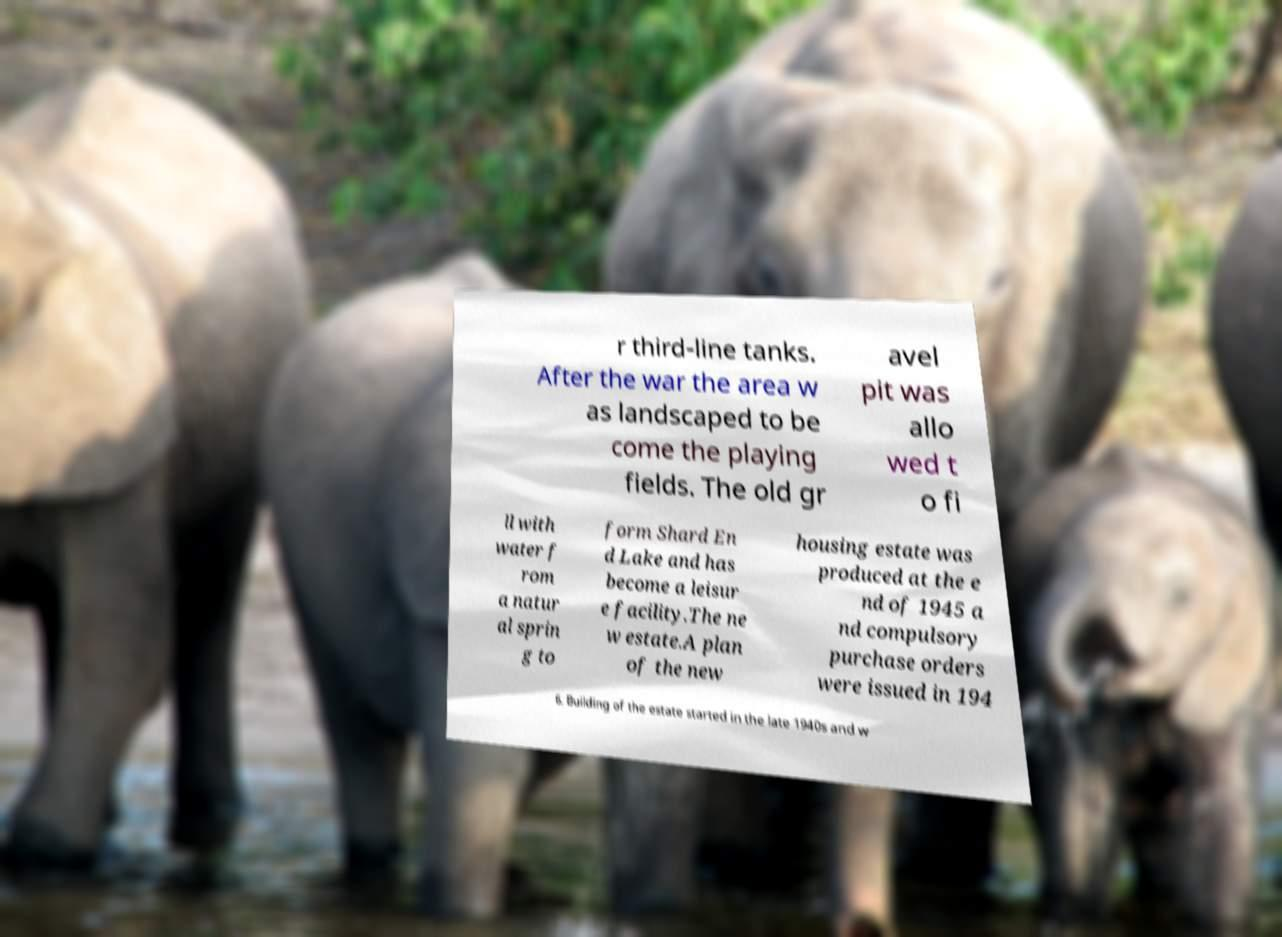What messages or text are displayed in this image? I need them in a readable, typed format. r third-line tanks. After the war the area w as landscaped to be come the playing fields. The old gr avel pit was allo wed t o fi ll with water f rom a natur al sprin g to form Shard En d Lake and has become a leisur e facility.The ne w estate.A plan of the new housing estate was produced at the e nd of 1945 a nd compulsory purchase orders were issued in 194 6. Building of the estate started in the late 1940s and w 